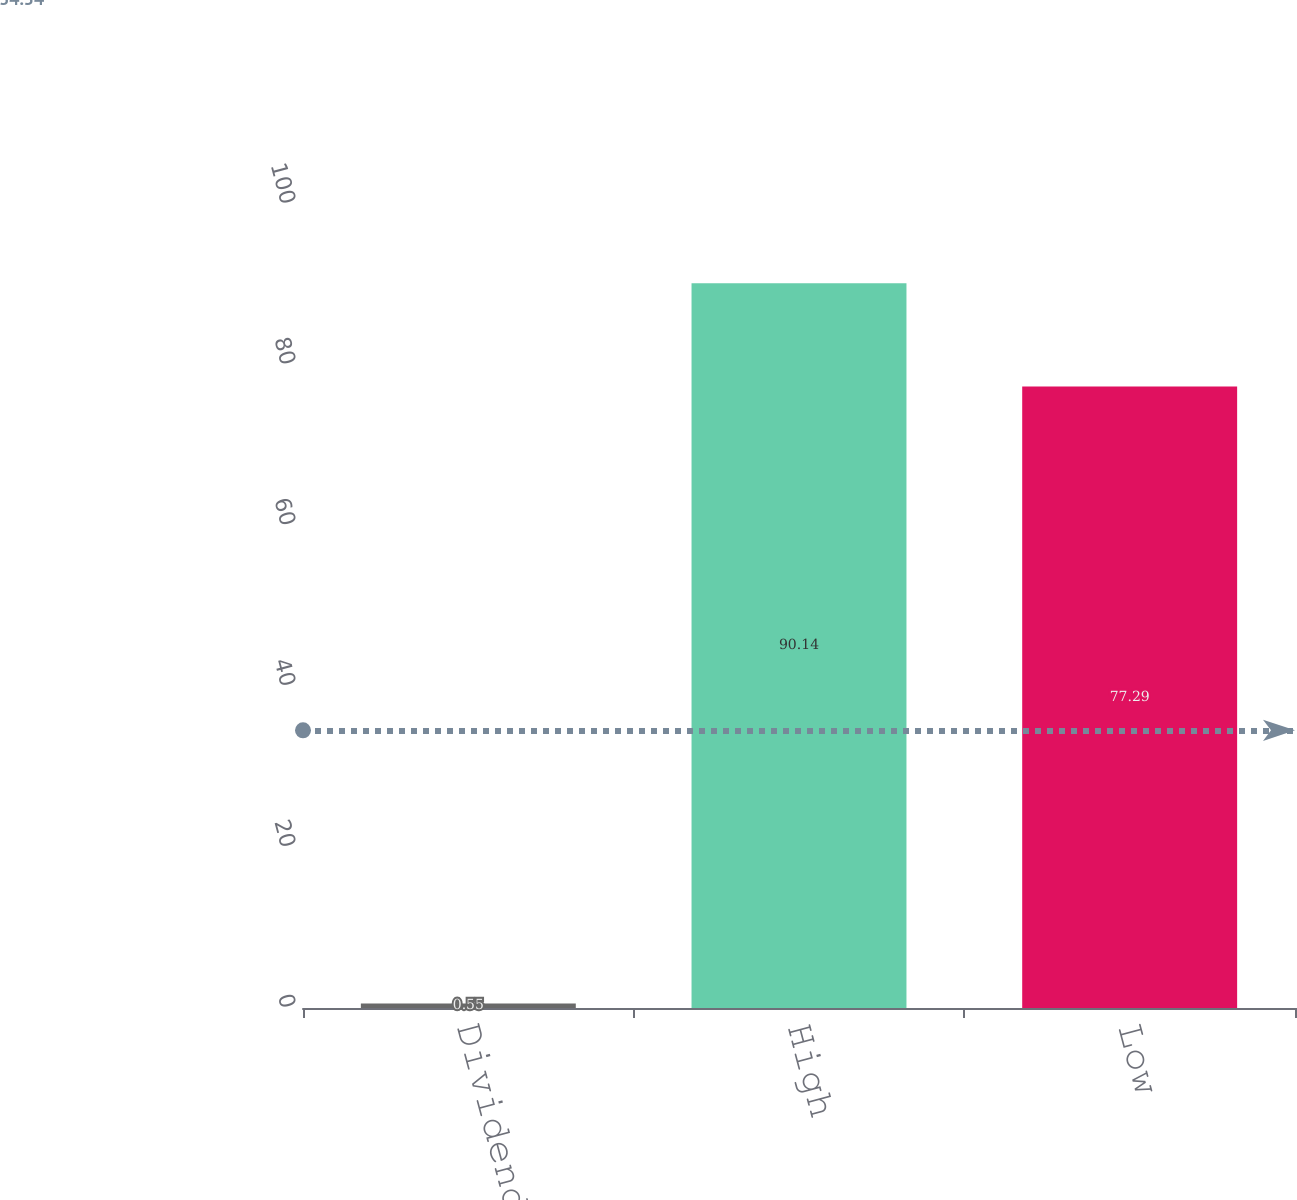<chart> <loc_0><loc_0><loc_500><loc_500><bar_chart><fcel>Dividends<fcel>High<fcel>Low<nl><fcel>0.55<fcel>90.14<fcel>77.29<nl></chart> 